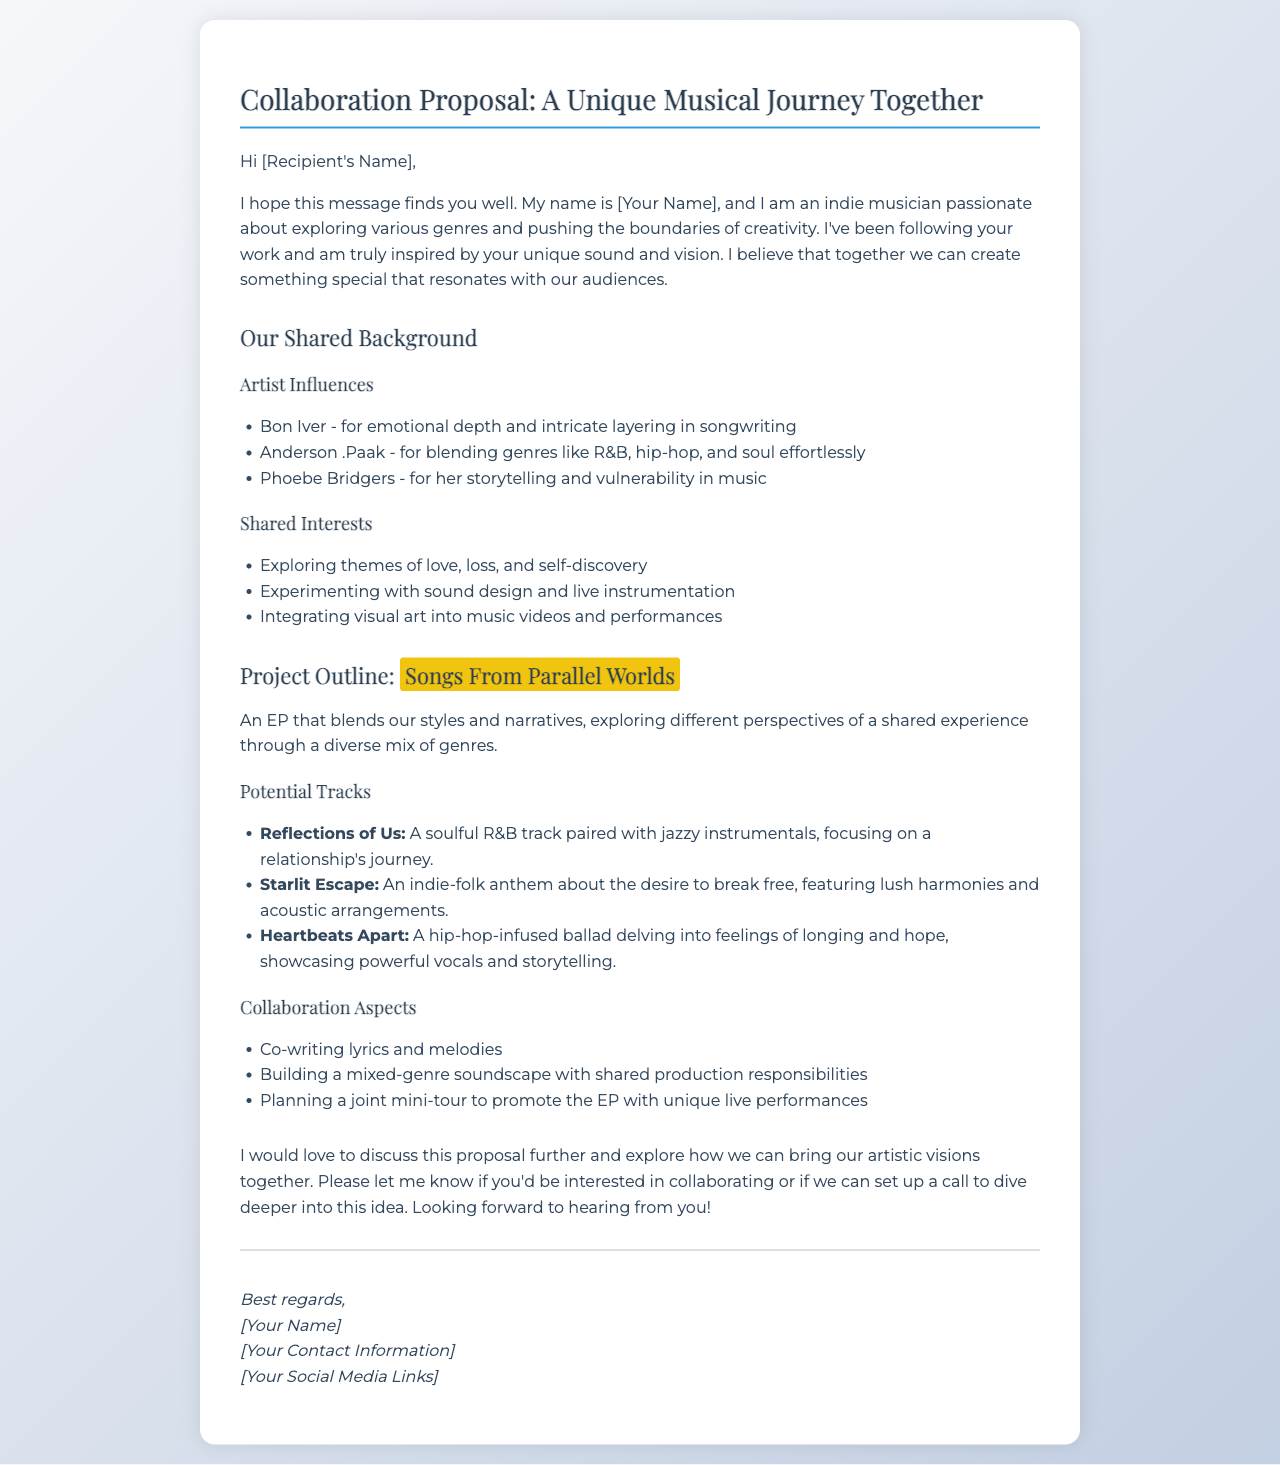What is the title of the project proposed in the document? The title of the proposed project is mentioned in the document as "Songs From Parallel Worlds".
Answer: Songs From Parallel Worlds Who are the three artist influences listed in the document? The document lists three artist influences: Bon Iver, Anderson .Paak, and Phoebe Bridgers.
Answer: Bon Iver, Anderson .Paak, Phoebe Bridgers What is the main theme explored in the project? The main theme explored in the project is a reflection on different perspectives of a shared experience.
Answer: Different perspectives of a shared experience How many potential tracks are suggested in the project outline? The document suggests three potential tracks for the project.
Answer: Three What collaboration aspect involves creating a joint promotion effort? The collaboration aspect that involves a joint promotion effort is "planning a joint mini-tour to promote the EP".
Answer: Planning a joint mini-tour to promote the EP What is the overall genre approach mentioned for the project? The overall genre approach mentioned for the project is a "diverse mix of genres".
Answer: Diverse mix of genres What type of music is "Reflections of Us"? The document categorizes "Reflections of Us" as a soulful R&B track.
Answer: Soulful R&B track What is the sender's intention at the end of the document? The sender's intention at the end of the document is to discuss the proposal further.
Answer: Discuss the proposal further 